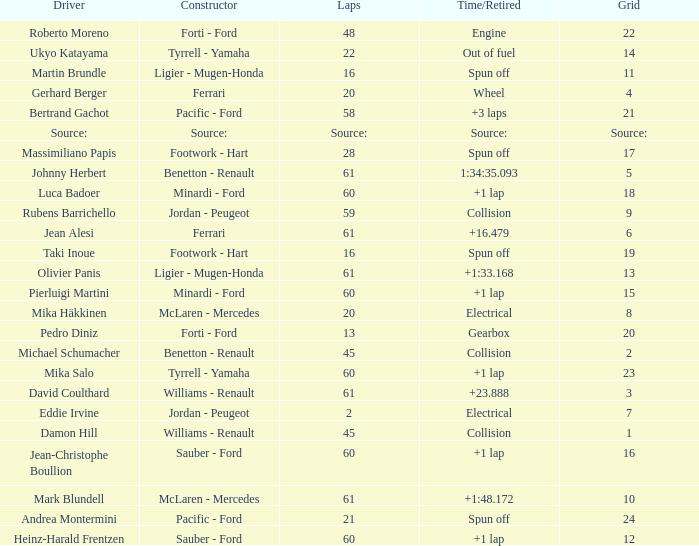How many laps does jean-christophe boullion have with a time/retired of +1 lap? 60.0. 